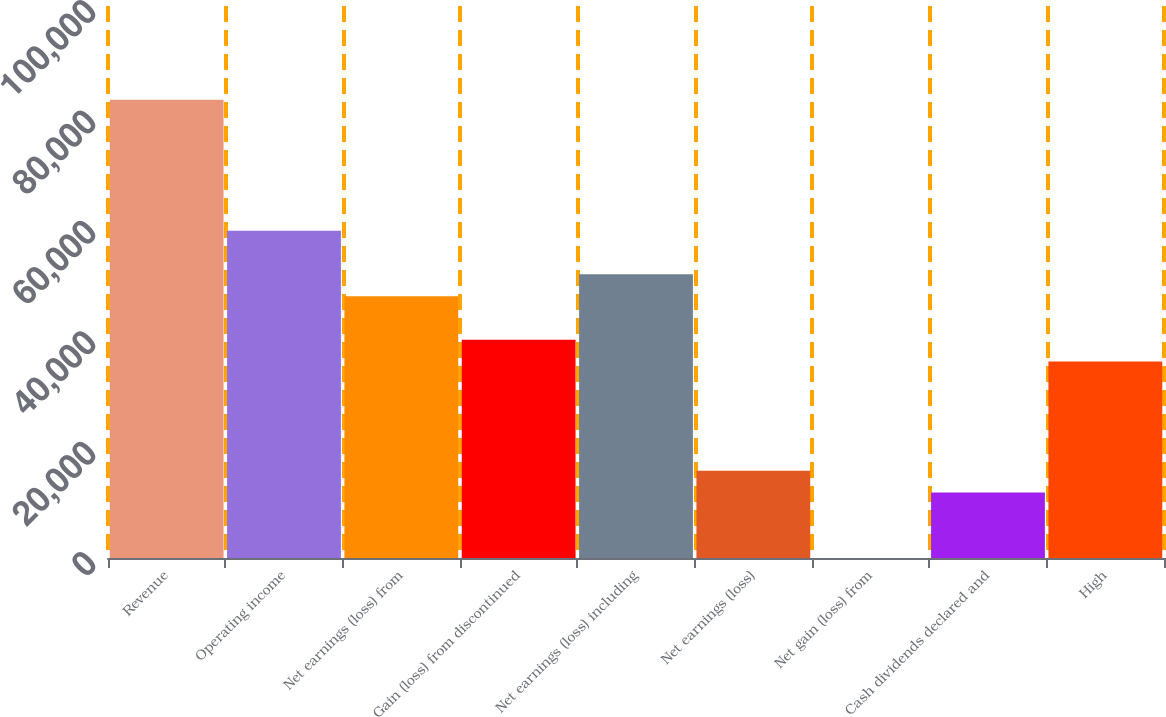Convert chart to OTSL. <chart><loc_0><loc_0><loc_500><loc_500><bar_chart><fcel>Revenue<fcel>Operating income<fcel>Net earnings (loss) from<fcel>Gain (loss) from discontinued<fcel>Net earnings (loss) including<fcel>Net earnings (loss)<fcel>Net gain (loss) from<fcel>Cash dividends declared and<fcel>High<nl><fcel>83008.4<fcel>59291.8<fcel>47433.5<fcel>39528<fcel>51386.3<fcel>15811.3<fcel>0.26<fcel>11858.6<fcel>35575.2<nl></chart> 